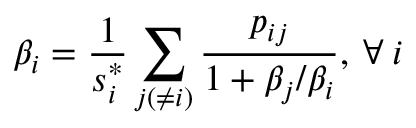<formula> <loc_0><loc_0><loc_500><loc_500>\beta _ { i } = \frac { 1 } { s _ { i } ^ { * } } \sum _ { j ( \neq i ) } \frac { p _ { i j } } { 1 + \beta _ { j } / \beta _ { i } } , \, \forall \, i</formula> 